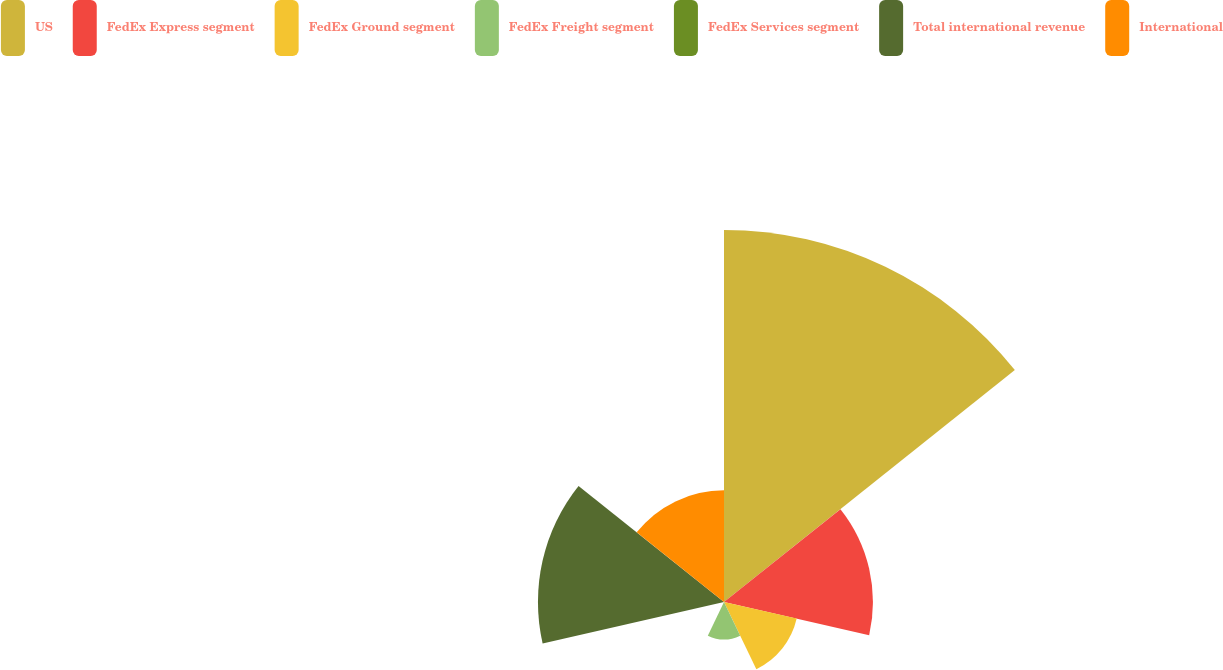Convert chart. <chart><loc_0><loc_0><loc_500><loc_500><pie_chart><fcel>US<fcel>FedEx Express segment<fcel>FedEx Ground segment<fcel>FedEx Freight segment<fcel>FedEx Services segment<fcel>Total international revenue<fcel>International<nl><fcel>39.97%<fcel>16.0%<fcel>8.01%<fcel>4.01%<fcel>0.01%<fcel>19.99%<fcel>12.0%<nl></chart> 